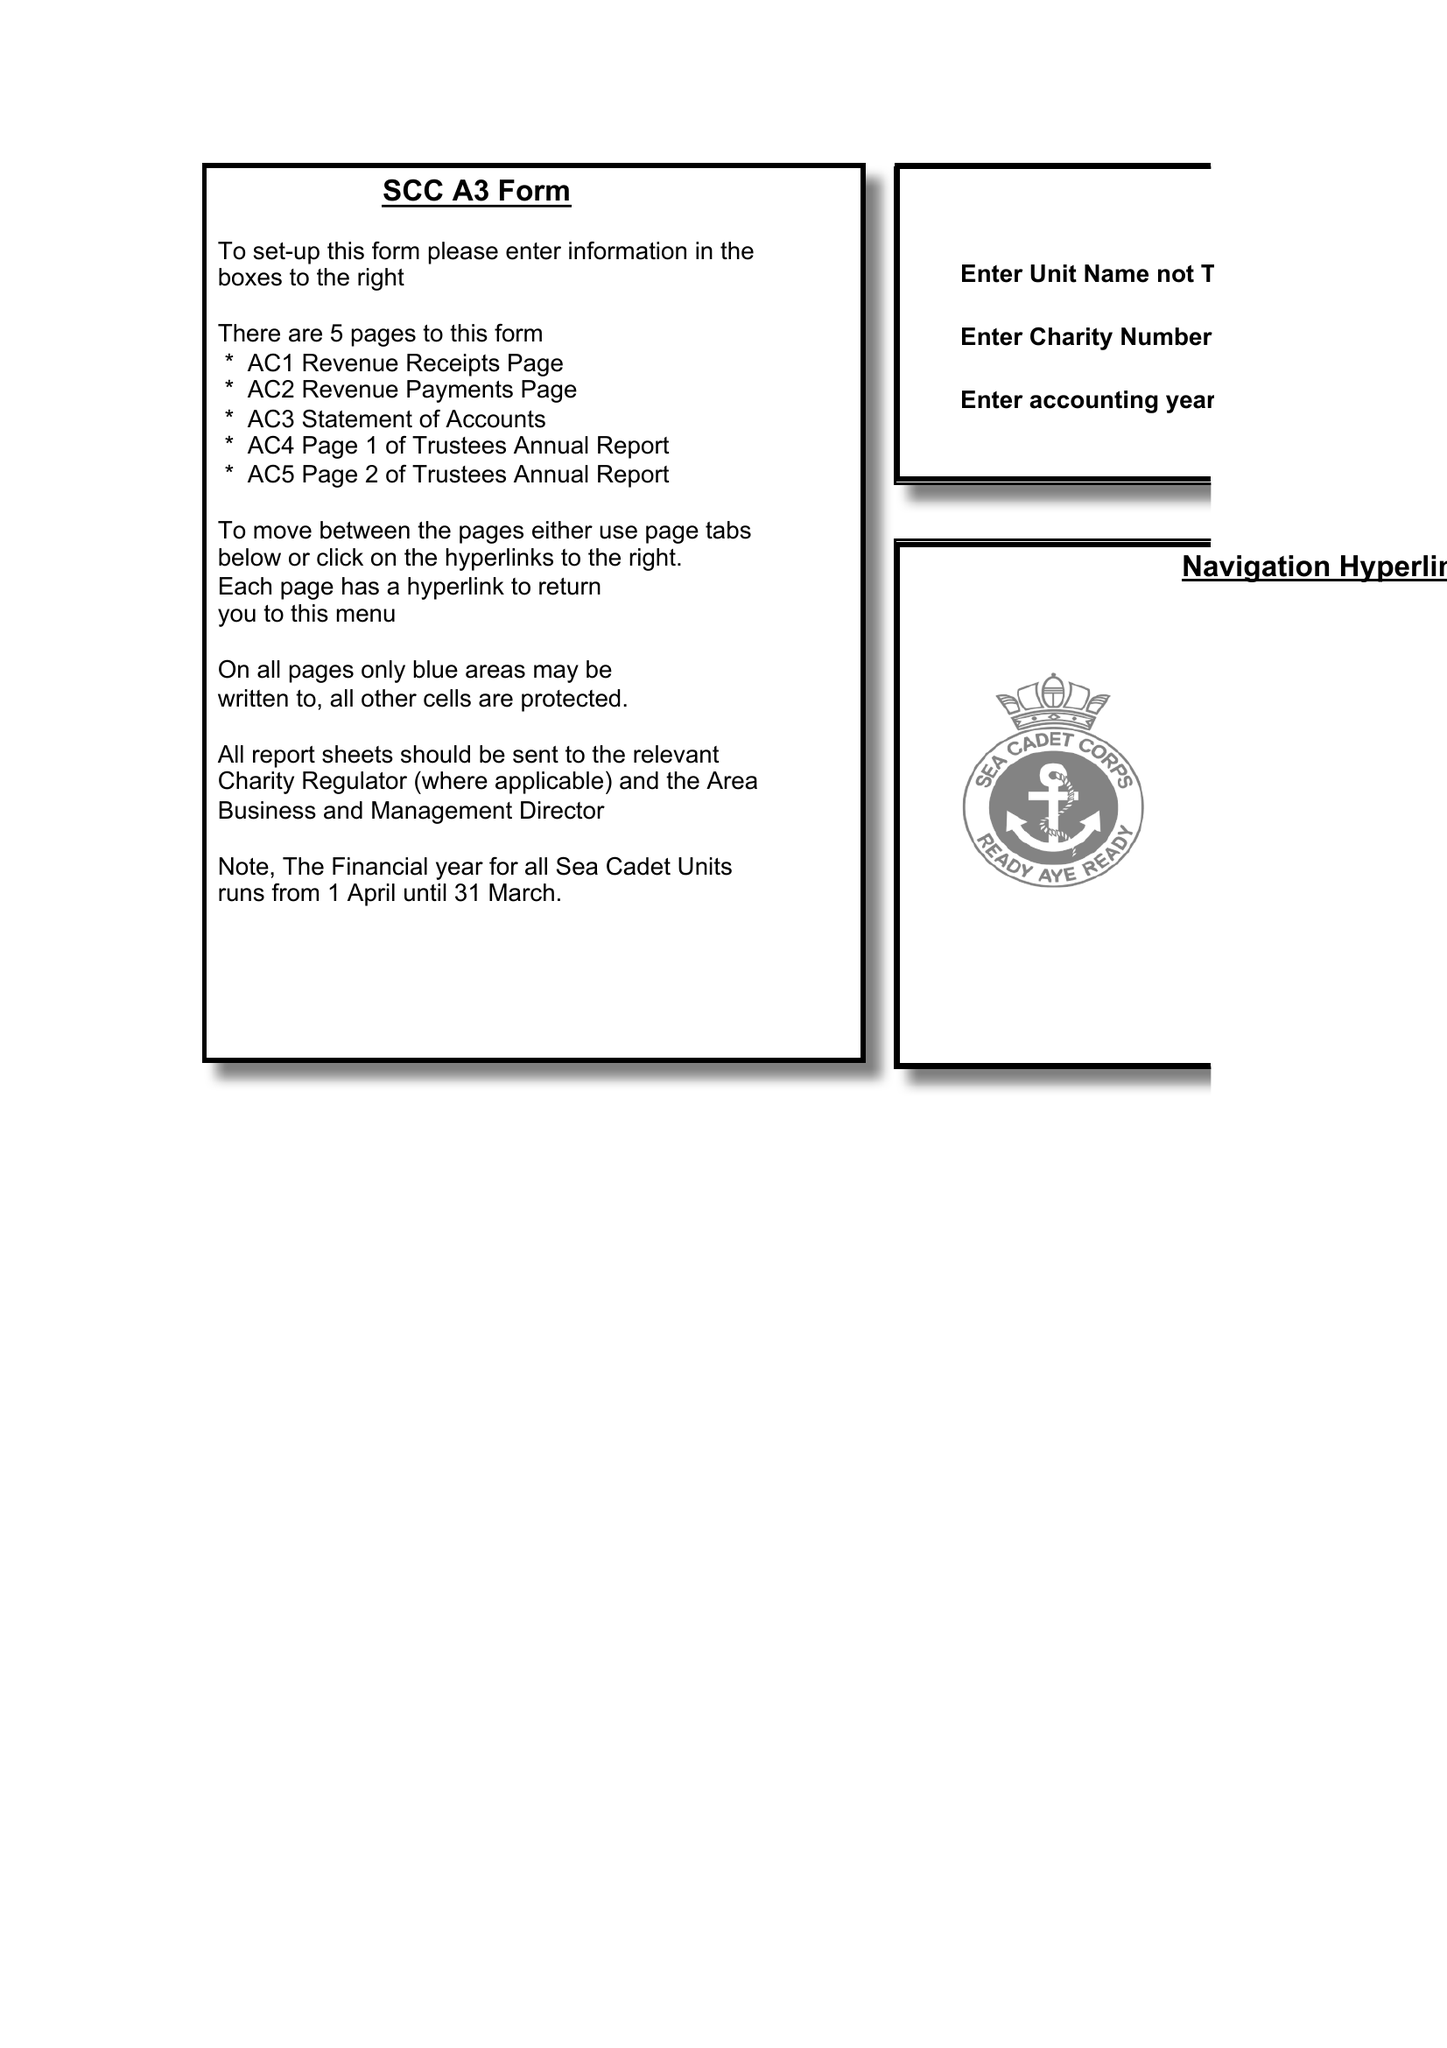What is the value for the income_annually_in_british_pounds?
Answer the question using a single word or phrase. 66688.22 